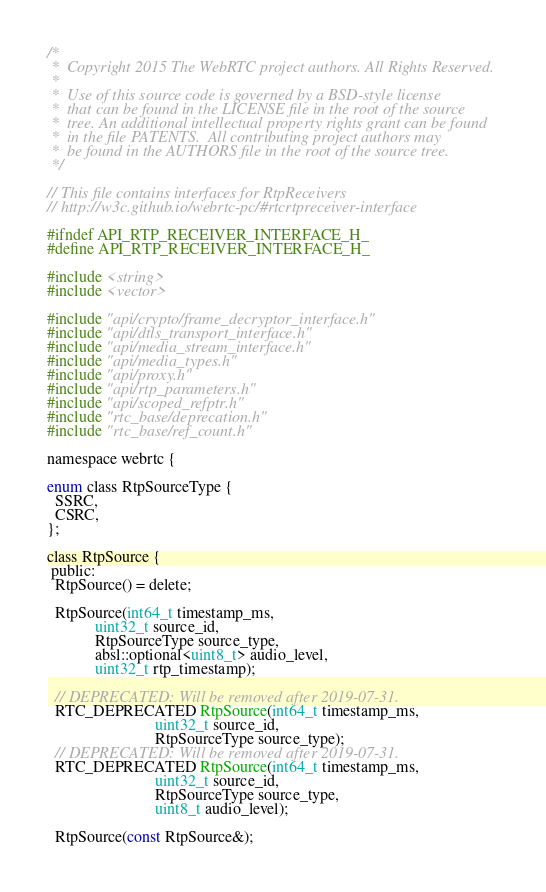Convert code to text. <code><loc_0><loc_0><loc_500><loc_500><_C_>/*
 *  Copyright 2015 The WebRTC project authors. All Rights Reserved.
 *
 *  Use of this source code is governed by a BSD-style license
 *  that can be found in the LICENSE file in the root of the source
 *  tree. An additional intellectual property rights grant can be found
 *  in the file PATENTS.  All contributing project authors may
 *  be found in the AUTHORS file in the root of the source tree.
 */

// This file contains interfaces for RtpReceivers
// http://w3c.github.io/webrtc-pc/#rtcrtpreceiver-interface

#ifndef API_RTP_RECEIVER_INTERFACE_H_
#define API_RTP_RECEIVER_INTERFACE_H_

#include <string>
#include <vector>

#include "api/crypto/frame_decryptor_interface.h"
#include "api/dtls_transport_interface.h"
#include "api/media_stream_interface.h"
#include "api/media_types.h"
#include "api/proxy.h"
#include "api/rtp_parameters.h"
#include "api/scoped_refptr.h"
#include "rtc_base/deprecation.h"
#include "rtc_base/ref_count.h"

namespace webrtc {

enum class RtpSourceType {
  SSRC,
  CSRC,
};

class RtpSource {
 public:
  RtpSource() = delete;

  RtpSource(int64_t timestamp_ms,
            uint32_t source_id,
            RtpSourceType source_type,
            absl::optional<uint8_t> audio_level,
            uint32_t rtp_timestamp);

  // DEPRECATED: Will be removed after 2019-07-31.
  RTC_DEPRECATED RtpSource(int64_t timestamp_ms,
                           uint32_t source_id,
                           RtpSourceType source_type);
  // DEPRECATED: Will be removed after 2019-07-31.
  RTC_DEPRECATED RtpSource(int64_t timestamp_ms,
                           uint32_t source_id,
                           RtpSourceType source_type,
                           uint8_t audio_level);

  RtpSource(const RtpSource&);</code> 